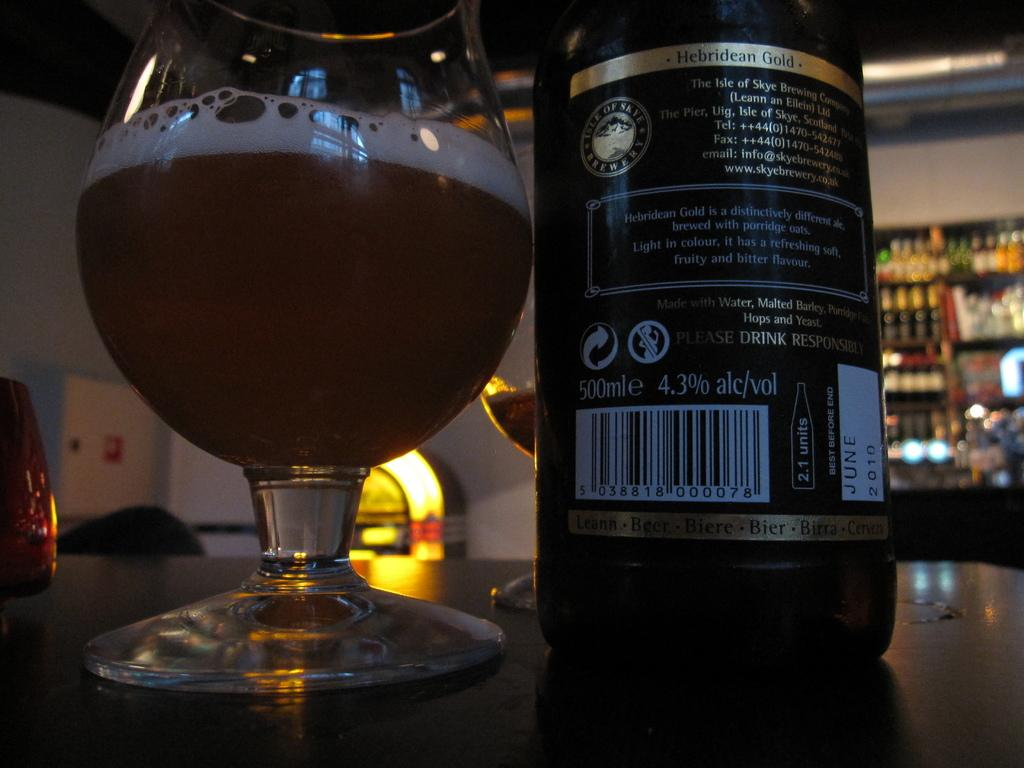What objects are on the table in the image? There are glasses and a bottle on the table in the image. Are there any other objects related to the glasses and bottle in the image? Yes, there is a shelf with bottles in the background of the image. How would you describe the background of the image? The background of the image is blurred. What is the opinion of the hose in the image? There is no hose present in the image, so it is not possible to determine its opinion. 